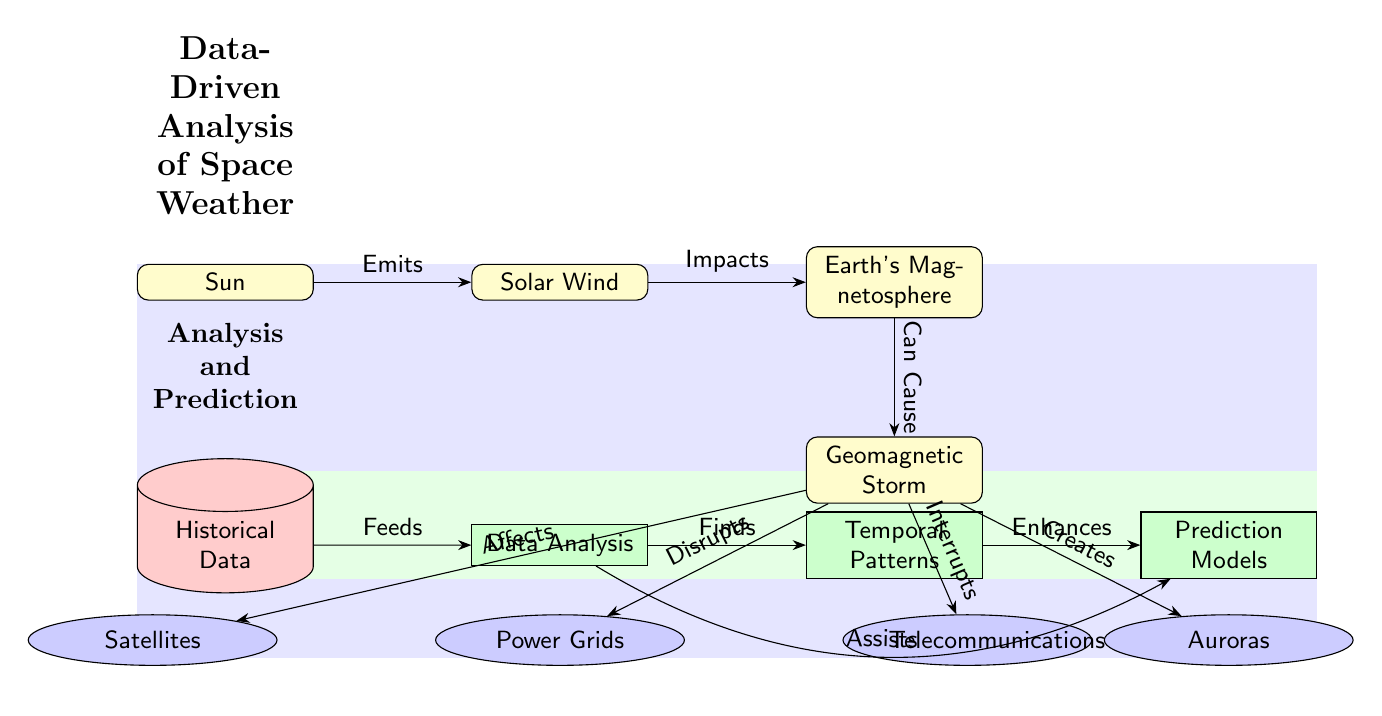What is the first event in the flow of the diagram? The first event in the flow is represented by the 'Sun' which emits solar wind. This is deduced by examining the topmost event node on the left side of the diagram.
Answer: Sun How many effects are listed as a consequence of geomagnetic storms? The diagram lists four effects flowing from geomagnetic storms: Power Grids, Satellites, Auroras, and Telecommunications. This is counted by reviewing the effects shaped as ellipses linked to the geomagnetic storm node.
Answer: 4 What process follows data analysis in the diagram? The process that follows data analysis is 'Temporal Patterns'. This is determined by looking at the sequence of processes to the right of the historical data node.
Answer: Temporal Patterns What does the historical data provide input to? The historical data feeds into the data analysis process. This is confirmed by observing the directed edge connecting the historical data to the data analysis node.
Answer: Data Analysis What role do solar winds play in the diagram? Solar winds impact Earth's magnetosphere, as shown by the directed edge from solar wind to magnetosphere indicating the flow of influence.
Answer: Impacts Which event is directly affected by geomagnetic storms? The event directly affected by geomagnetic storms is the 'Power Grids'. This is identified by checking the edges leading from geomagnetic storms, specifically the edge that labels 'Disrupts'.
Answer: Power Grids What is the last node in the analysis and prediction section? The last node in the analysis and prediction section is 'Prediction Models'. This is found by examining the rightmost part of the diagram, concluding the flow of processes in that section.
Answer: Prediction Models What type of data is represented in the bottom section of the diagram? The type of data represented in the bottom section is 'Historical Data', depicted as a cylinder-shaped node indicating its role as data input in the analysis processes.
Answer: Historical Data How many main events are depicted in the first sequence of the diagram? There are three main events depicted in the first sequence: Sun, Solar Wind, and Earth's Magnetosphere. This is ascertained by counting the event nodes along that path on the upper portion of the diagram.
Answer: 3 